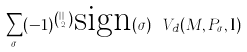<formula> <loc_0><loc_0><loc_500><loc_500>\sum _ { \sigma } ( - 1 ) ^ { \binom { | I | } { 2 } } \text {sign} ( \sigma ) \ V _ { d } ( M , P _ { \sigma } , { \mathbf l } )</formula> 